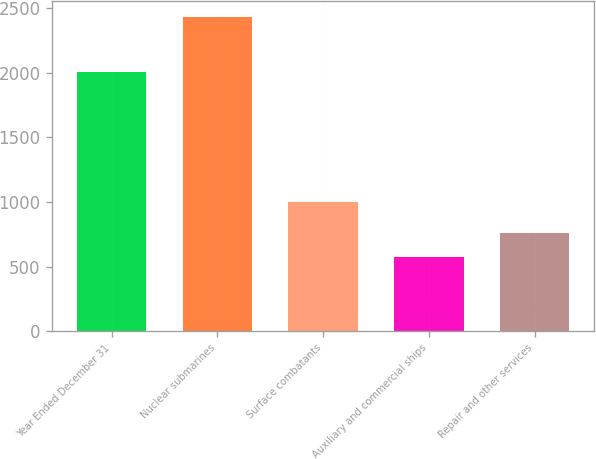Convert chart to OTSL. <chart><loc_0><loc_0><loc_500><loc_500><bar_chart><fcel>Year Ended December 31<fcel>Nuclear submarines<fcel>Surface combatants<fcel>Auxiliary and commercial ships<fcel>Repair and other services<nl><fcel>2004<fcel>2432<fcel>1002<fcel>576<fcel>761.6<nl></chart> 